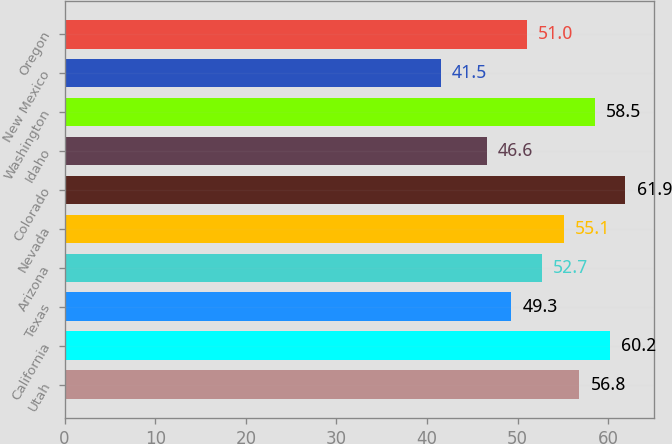Convert chart to OTSL. <chart><loc_0><loc_0><loc_500><loc_500><bar_chart><fcel>Utah<fcel>California<fcel>Texas<fcel>Arizona<fcel>Nevada<fcel>Colorado<fcel>Idaho<fcel>Washington<fcel>New Mexico<fcel>Oregon<nl><fcel>56.8<fcel>60.2<fcel>49.3<fcel>52.7<fcel>55.1<fcel>61.9<fcel>46.6<fcel>58.5<fcel>41.5<fcel>51<nl></chart> 